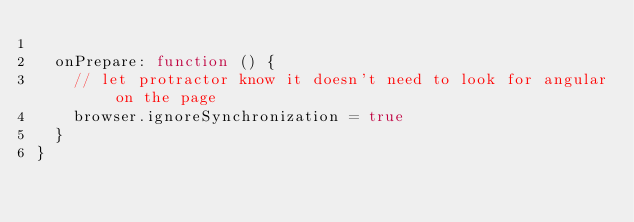Convert code to text. <code><loc_0><loc_0><loc_500><loc_500><_JavaScript_>
  onPrepare: function () {
    // let protractor know it doesn't need to look for angular on the page
    browser.ignoreSynchronization = true
  }
}

</code> 